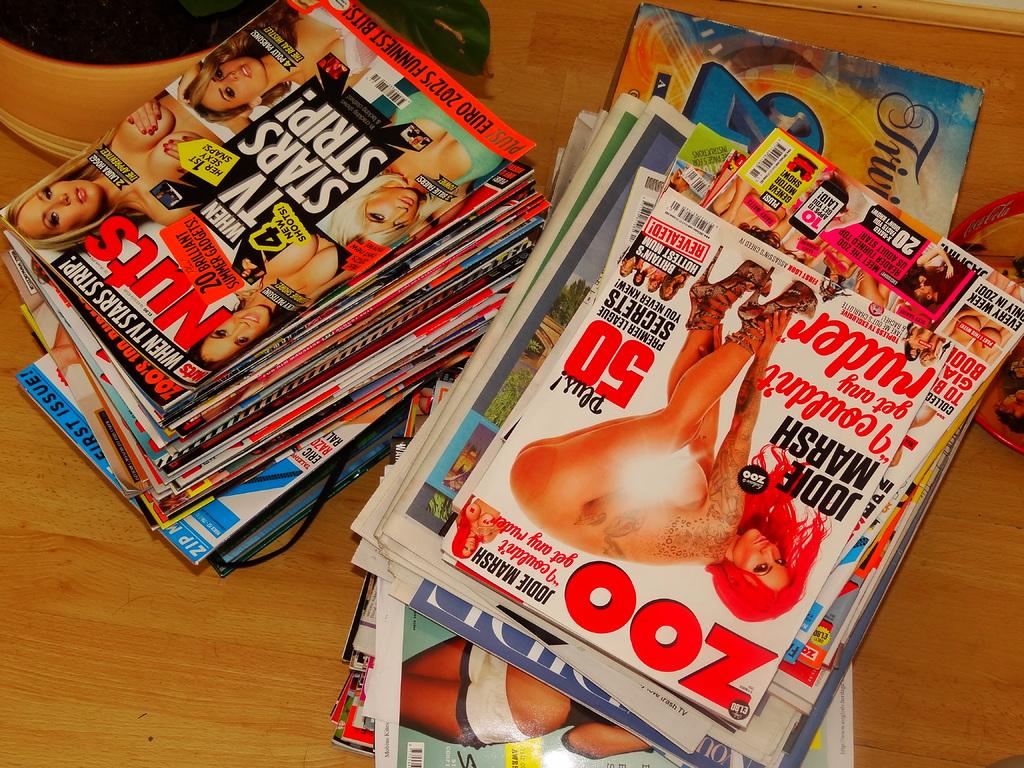What is the title of the right magazine on top?
Offer a terse response. Zoo. What is the title of the left magazine?
Ensure brevity in your answer.  Nuts. 